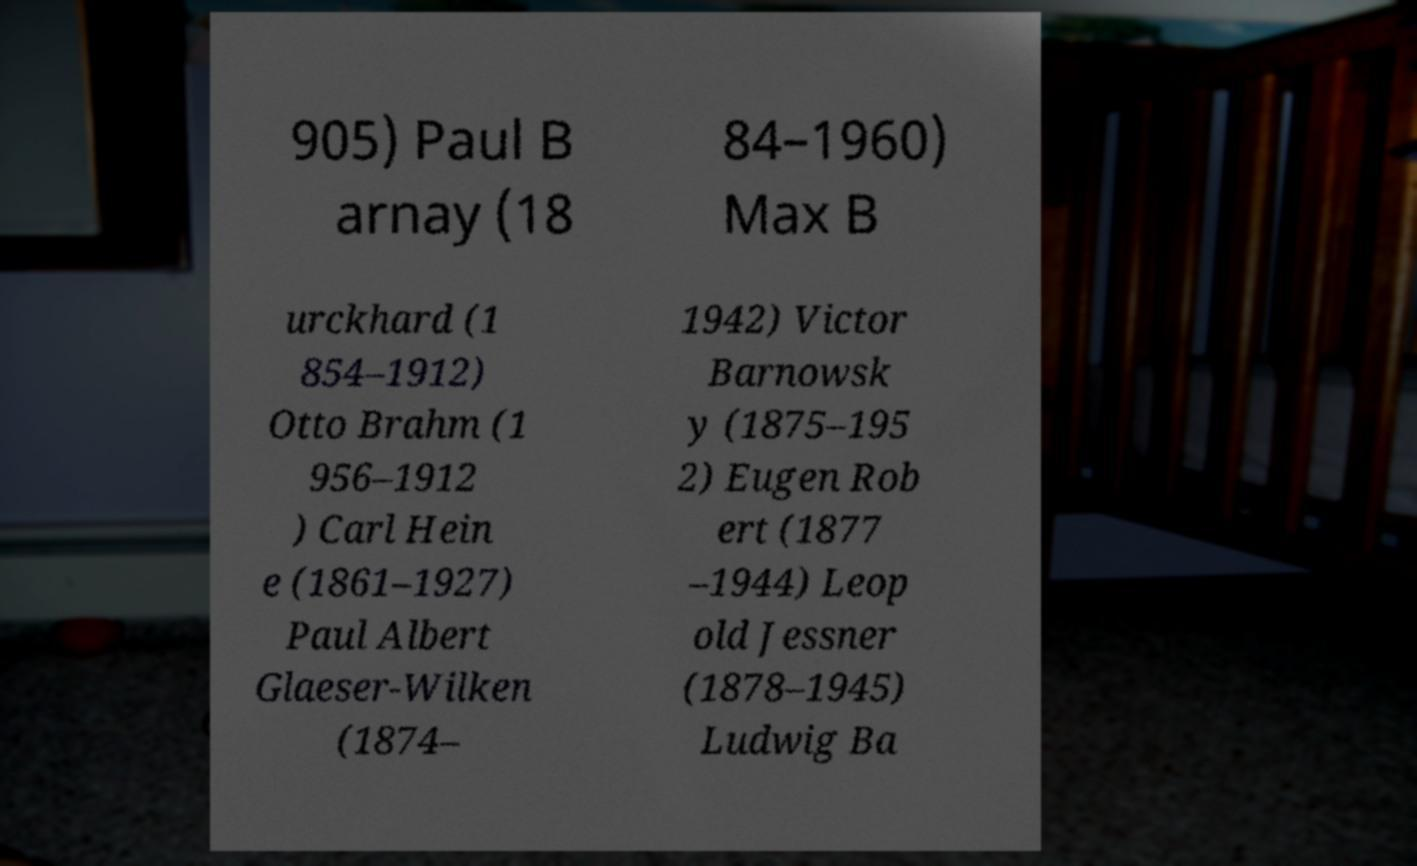Could you extract and type out the text from this image? 905) Paul B arnay (18 84–1960) Max B urckhard (1 854–1912) Otto Brahm (1 956–1912 ) Carl Hein e (1861–1927) Paul Albert Glaeser-Wilken (1874– 1942) Victor Barnowsk y (1875–195 2) Eugen Rob ert (1877 –1944) Leop old Jessner (1878–1945) Ludwig Ba 